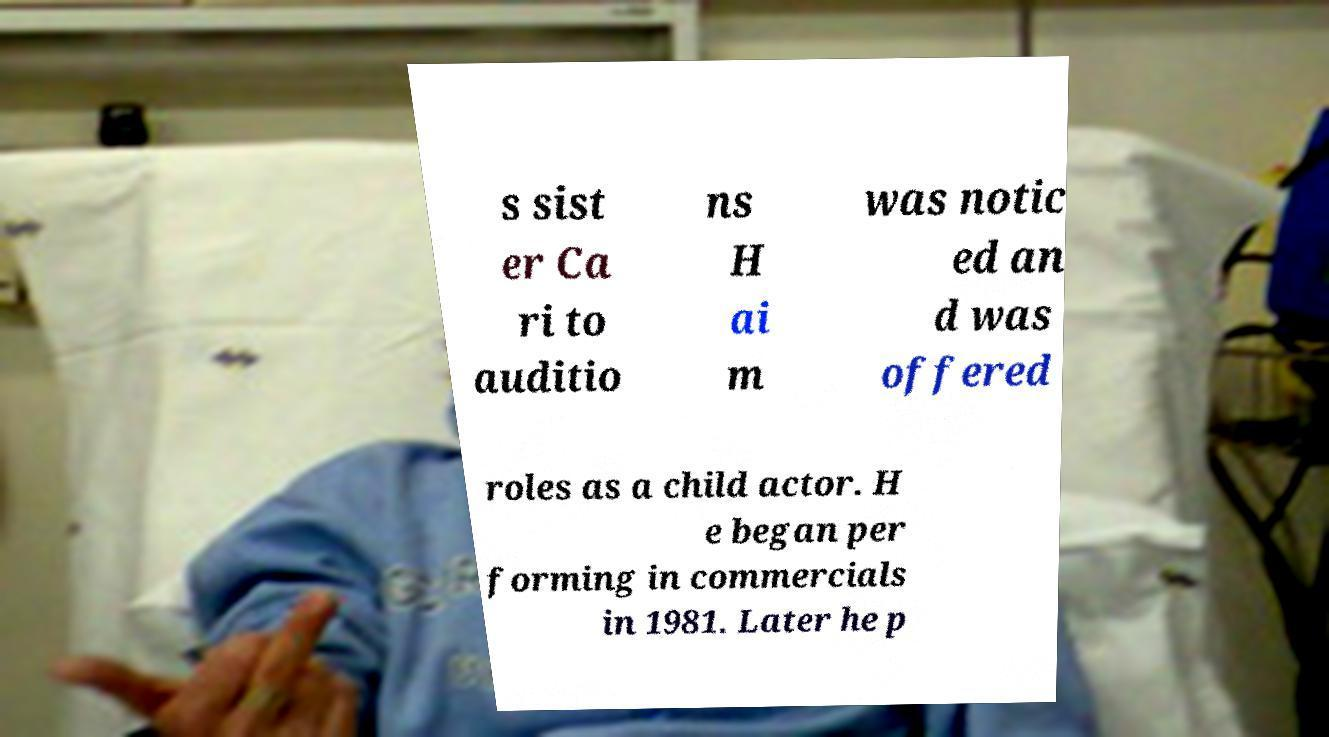Can you read and provide the text displayed in the image?This photo seems to have some interesting text. Can you extract and type it out for me? s sist er Ca ri to auditio ns H ai m was notic ed an d was offered roles as a child actor. H e began per forming in commercials in 1981. Later he p 